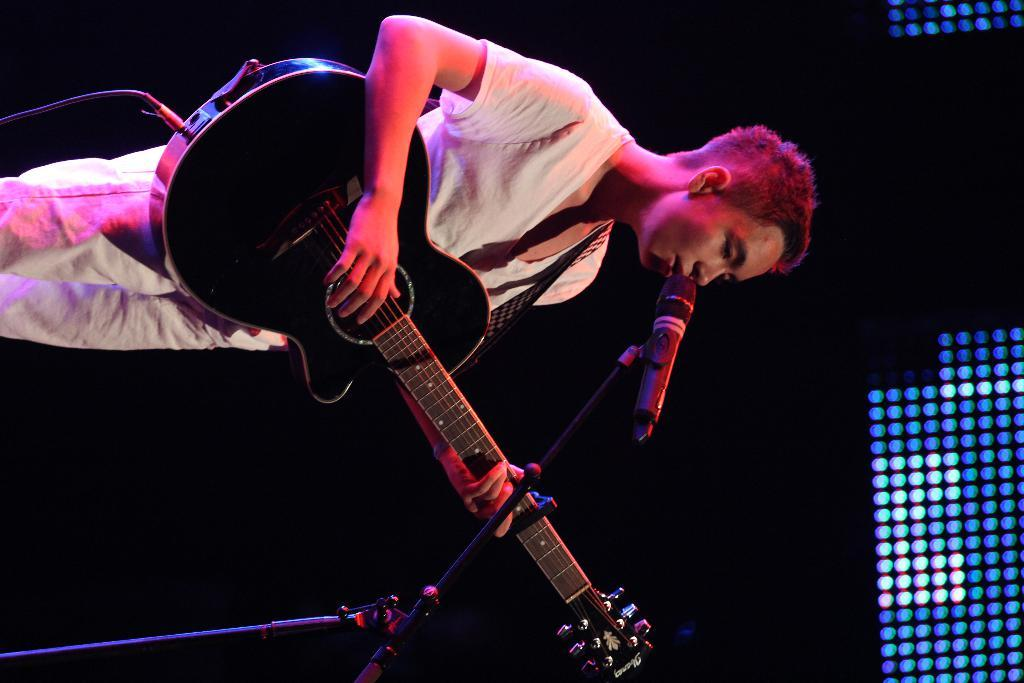Who is the main subject in the image? There is a man in the image. What is the man doing in the image? The man is standing in the image. What object is the man holding in the image? The man is holding a guitar in the image. What is the purpose of the microphone in front of the man? The microphone in front of the man is likely for amplifying his voice or guitar playing. What type of milk is the man drinking in the image? There is no milk present in the image; the man is holding a guitar and standing near a microphone. 